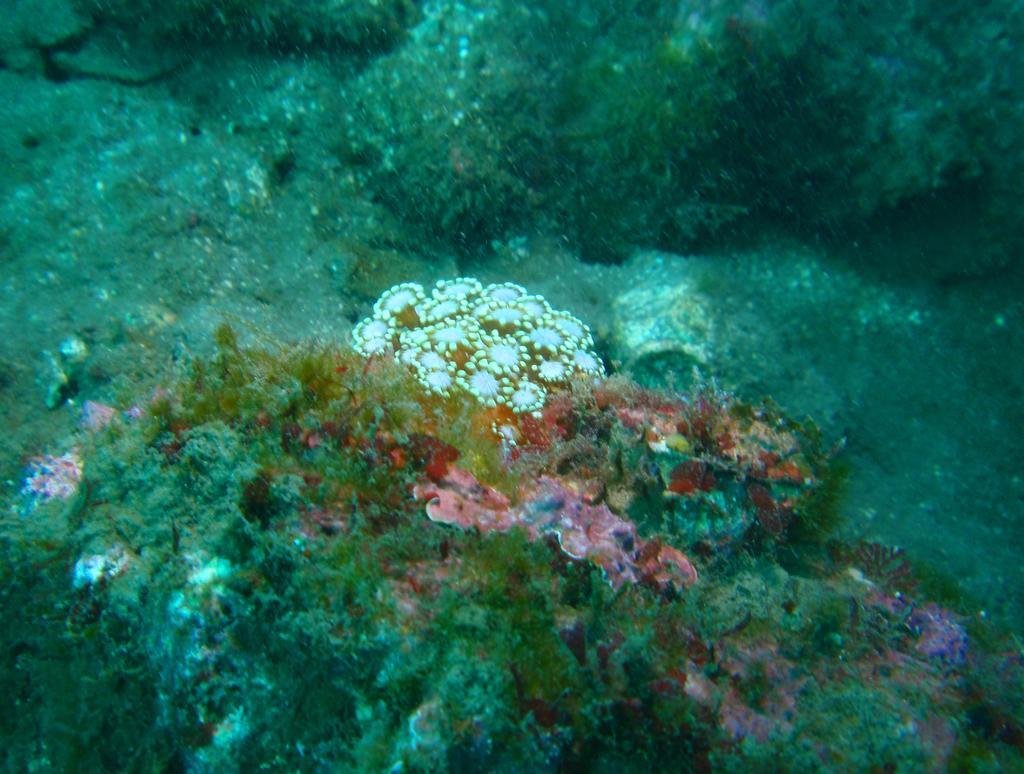In one or two sentences, can you explain what this image depicts? In this picture we can see the underwater plants. In the center we can see the flowers and other objects. 